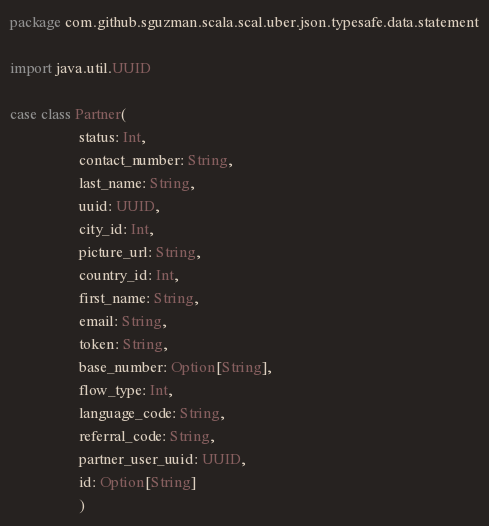<code> <loc_0><loc_0><loc_500><loc_500><_Scala_>package com.github.sguzman.scala.scal.uber.json.typesafe.data.statement

import java.util.UUID

case class Partner(
                  status: Int,
                  contact_number: String,
                  last_name: String,
                  uuid: UUID,
                  city_id: Int,
                  picture_url: String,
                  country_id: Int,
                  first_name: String,
                  email: String,
                  token: String,
                  base_number: Option[String],
                  flow_type: Int,
                  language_code: String,
                  referral_code: String,
                  partner_user_uuid: UUID,
                  id: Option[String]
                  )
</code> 